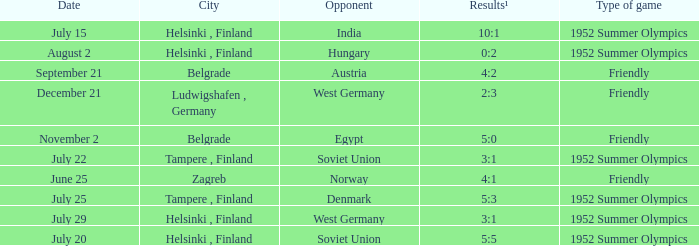What Type of game was played on Date of July 29? 1952 Summer Olympics. 